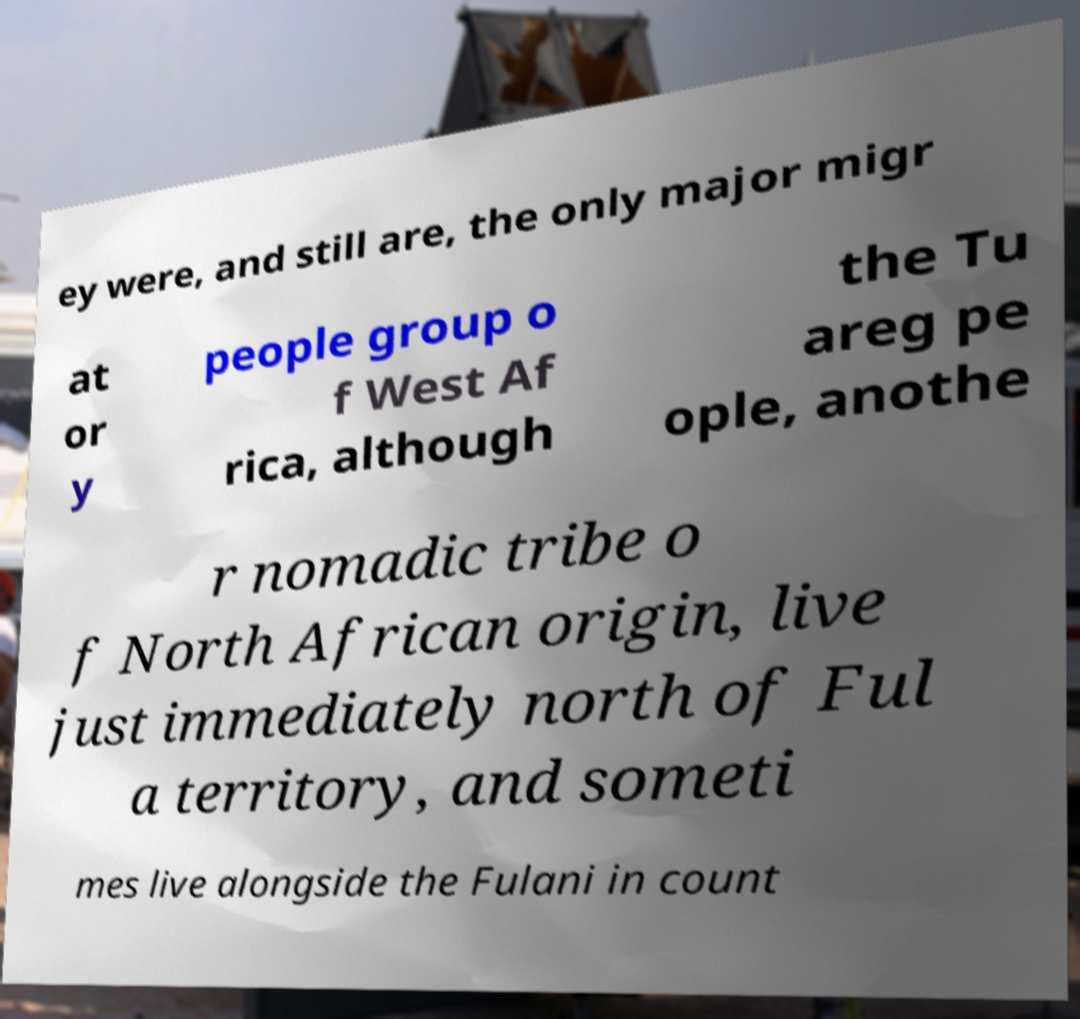What messages or text are displayed in this image? I need them in a readable, typed format. ey were, and still are, the only major migr at or y people group o f West Af rica, although the Tu areg pe ople, anothe r nomadic tribe o f North African origin, live just immediately north of Ful a territory, and someti mes live alongside the Fulani in count 